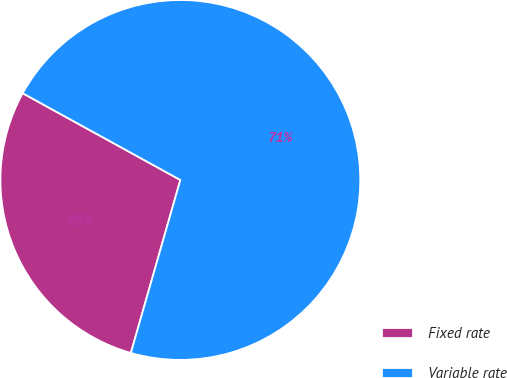<chart> <loc_0><loc_0><loc_500><loc_500><pie_chart><fcel>Fixed rate<fcel>Variable rate<nl><fcel>28.57%<fcel>71.43%<nl></chart> 